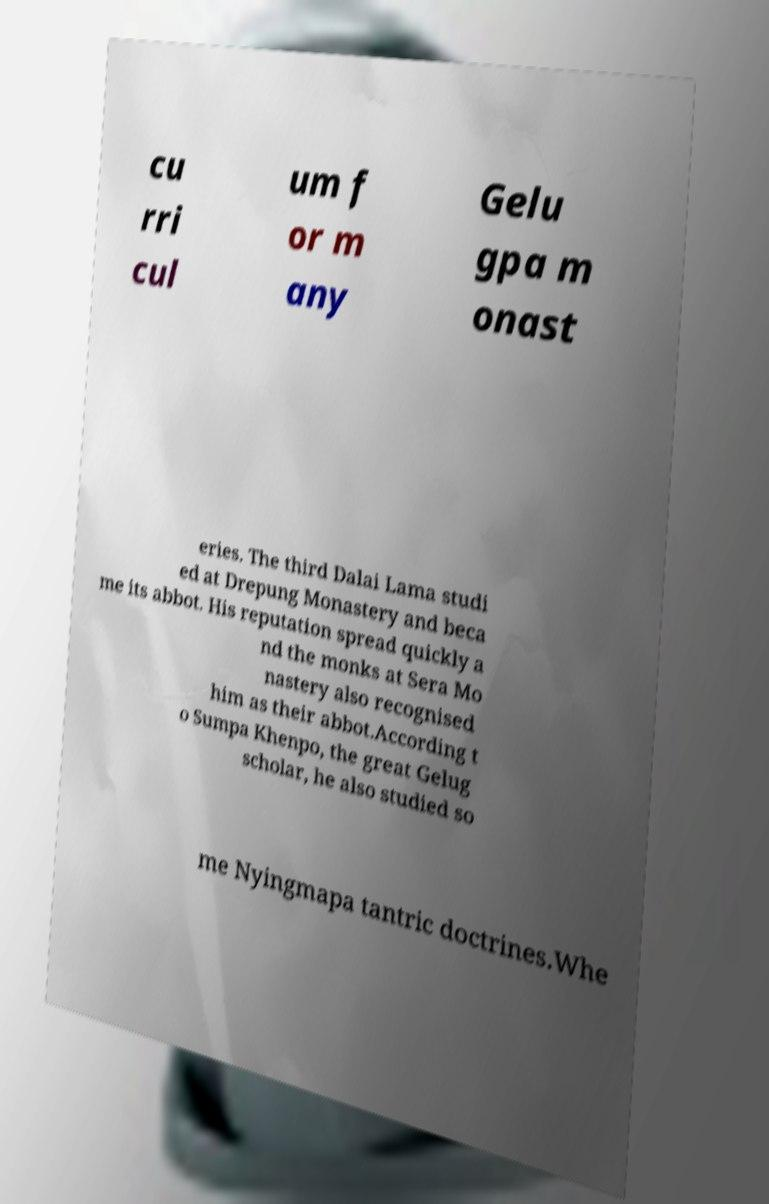There's text embedded in this image that I need extracted. Can you transcribe it verbatim? cu rri cul um f or m any Gelu gpa m onast eries. The third Dalai Lama studi ed at Drepung Monastery and beca me its abbot. His reputation spread quickly a nd the monks at Sera Mo nastery also recognised him as their abbot.According t o Sumpa Khenpo, the great Gelug scholar, he also studied so me Nyingmapa tantric doctrines.Whe 